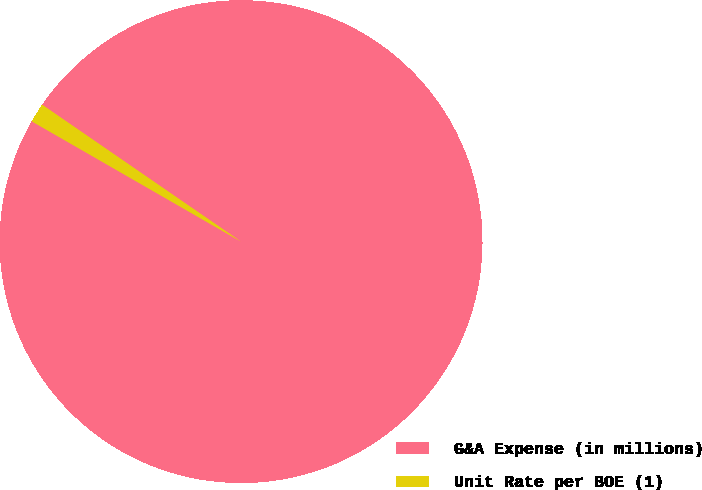Convert chart. <chart><loc_0><loc_0><loc_500><loc_500><pie_chart><fcel>G&A Expense (in millions)<fcel>Unit Rate per BOE (1)<nl><fcel>98.71%<fcel>1.29%<nl></chart> 